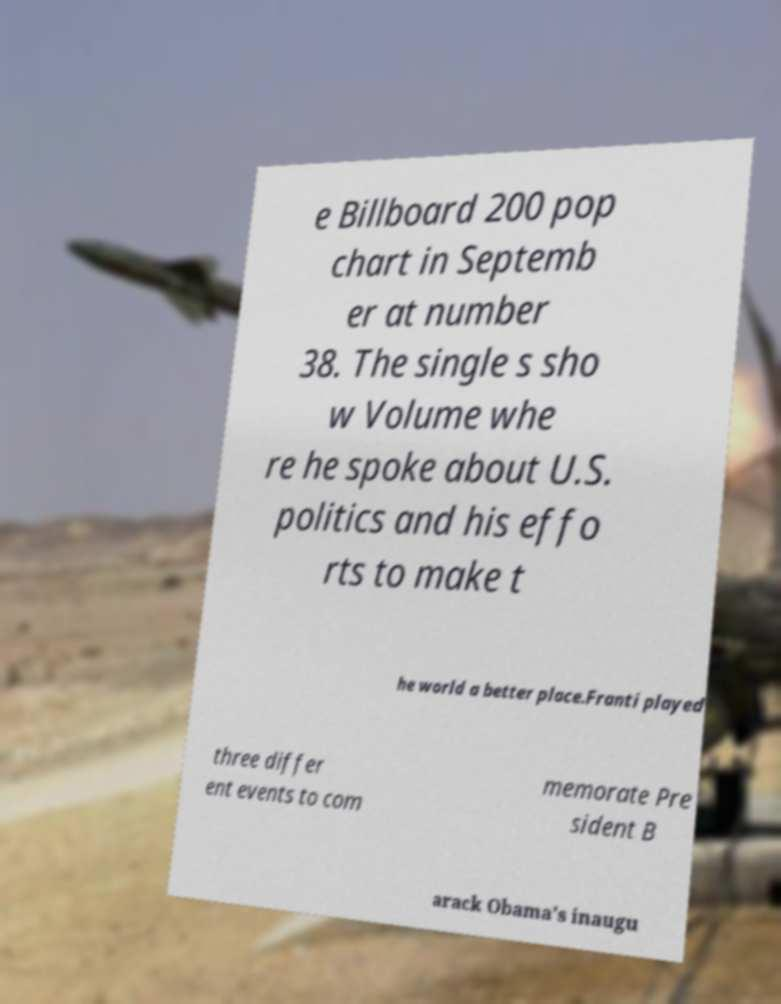Could you assist in decoding the text presented in this image and type it out clearly? e Billboard 200 pop chart in Septemb er at number 38. The single s sho w Volume whe re he spoke about U.S. politics and his effo rts to make t he world a better place.Franti played three differ ent events to com memorate Pre sident B arack Obama's inaugu 